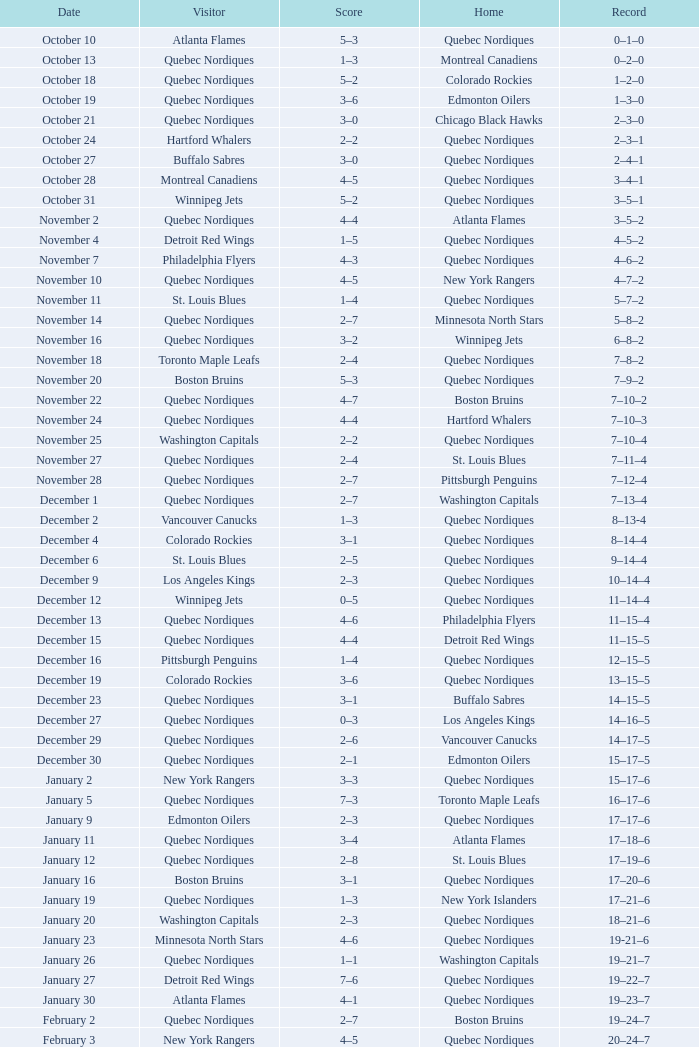Could you parse the entire table? {'header': ['Date', 'Visitor', 'Score', 'Home', 'Record'], 'rows': [['October 10', 'Atlanta Flames', '5–3', 'Quebec Nordiques', '0–1–0'], ['October 13', 'Quebec Nordiques', '1–3', 'Montreal Canadiens', '0–2–0'], ['October 18', 'Quebec Nordiques', '5–2', 'Colorado Rockies', '1–2–0'], ['October 19', 'Quebec Nordiques', '3–6', 'Edmonton Oilers', '1–3–0'], ['October 21', 'Quebec Nordiques', '3–0', 'Chicago Black Hawks', '2–3–0'], ['October 24', 'Hartford Whalers', '2–2', 'Quebec Nordiques', '2–3–1'], ['October 27', 'Buffalo Sabres', '3–0', 'Quebec Nordiques', '2–4–1'], ['October 28', 'Montreal Canadiens', '4–5', 'Quebec Nordiques', '3–4–1'], ['October 31', 'Winnipeg Jets', '5–2', 'Quebec Nordiques', '3–5–1'], ['November 2', 'Quebec Nordiques', '4–4', 'Atlanta Flames', '3–5–2'], ['November 4', 'Detroit Red Wings', '1–5', 'Quebec Nordiques', '4–5–2'], ['November 7', 'Philadelphia Flyers', '4–3', 'Quebec Nordiques', '4–6–2'], ['November 10', 'Quebec Nordiques', '4–5', 'New York Rangers', '4–7–2'], ['November 11', 'St. Louis Blues', '1–4', 'Quebec Nordiques', '5–7–2'], ['November 14', 'Quebec Nordiques', '2–7', 'Minnesota North Stars', '5–8–2'], ['November 16', 'Quebec Nordiques', '3–2', 'Winnipeg Jets', '6–8–2'], ['November 18', 'Toronto Maple Leafs', '2–4', 'Quebec Nordiques', '7–8–2'], ['November 20', 'Boston Bruins', '5–3', 'Quebec Nordiques', '7–9–2'], ['November 22', 'Quebec Nordiques', '4–7', 'Boston Bruins', '7–10–2'], ['November 24', 'Quebec Nordiques', '4–4', 'Hartford Whalers', '7–10–3'], ['November 25', 'Washington Capitals', '2–2', 'Quebec Nordiques', '7–10–4'], ['November 27', 'Quebec Nordiques', '2–4', 'St. Louis Blues', '7–11–4'], ['November 28', 'Quebec Nordiques', '2–7', 'Pittsburgh Penguins', '7–12–4'], ['December 1', 'Quebec Nordiques', '2–7', 'Washington Capitals', '7–13–4'], ['December 2', 'Vancouver Canucks', '1–3', 'Quebec Nordiques', '8–13-4'], ['December 4', 'Colorado Rockies', '3–1', 'Quebec Nordiques', '8–14–4'], ['December 6', 'St. Louis Blues', '2–5', 'Quebec Nordiques', '9–14–4'], ['December 9', 'Los Angeles Kings', '2–3', 'Quebec Nordiques', '10–14–4'], ['December 12', 'Winnipeg Jets', '0–5', 'Quebec Nordiques', '11–14–4'], ['December 13', 'Quebec Nordiques', '4–6', 'Philadelphia Flyers', '11–15–4'], ['December 15', 'Quebec Nordiques', '4–4', 'Detroit Red Wings', '11–15–5'], ['December 16', 'Pittsburgh Penguins', '1–4', 'Quebec Nordiques', '12–15–5'], ['December 19', 'Colorado Rockies', '3–6', 'Quebec Nordiques', '13–15–5'], ['December 23', 'Quebec Nordiques', '3–1', 'Buffalo Sabres', '14–15–5'], ['December 27', 'Quebec Nordiques', '0–3', 'Los Angeles Kings', '14–16–5'], ['December 29', 'Quebec Nordiques', '2–6', 'Vancouver Canucks', '14–17–5'], ['December 30', 'Quebec Nordiques', '2–1', 'Edmonton Oilers', '15–17–5'], ['January 2', 'New York Rangers', '3–3', 'Quebec Nordiques', '15–17–6'], ['January 5', 'Quebec Nordiques', '7–3', 'Toronto Maple Leafs', '16–17–6'], ['January 9', 'Edmonton Oilers', '2–3', 'Quebec Nordiques', '17–17–6'], ['January 11', 'Quebec Nordiques', '3–4', 'Atlanta Flames', '17–18–6'], ['January 12', 'Quebec Nordiques', '2–8', 'St. Louis Blues', '17–19–6'], ['January 16', 'Boston Bruins', '3–1', 'Quebec Nordiques', '17–20–6'], ['January 19', 'Quebec Nordiques', '1–3', 'New York Islanders', '17–21–6'], ['January 20', 'Washington Capitals', '2–3', 'Quebec Nordiques', '18–21–6'], ['January 23', 'Minnesota North Stars', '4–6', 'Quebec Nordiques', '19-21–6'], ['January 26', 'Quebec Nordiques', '1–1', 'Washington Capitals', '19–21–7'], ['January 27', 'Detroit Red Wings', '7–6', 'Quebec Nordiques', '19–22–7'], ['January 30', 'Atlanta Flames', '4–1', 'Quebec Nordiques', '19–23–7'], ['February 2', 'Quebec Nordiques', '2–7', 'Boston Bruins', '19–24–7'], ['February 3', 'New York Rangers', '4–5', 'Quebec Nordiques', '20–24–7'], ['February 6', 'Chicago Black Hawks', '3–3', 'Quebec Nordiques', '20–24–8'], ['February 9', 'Quebec Nordiques', '0–5', 'New York Islanders', '20–25–8'], ['February 10', 'Quebec Nordiques', '1–3', 'New York Rangers', '20–26–8'], ['February 14', 'Quebec Nordiques', '1–5', 'Montreal Canadiens', '20–27–8'], ['February 17', 'Quebec Nordiques', '5–6', 'Winnipeg Jets', '20–28–8'], ['February 18', 'Quebec Nordiques', '2–6', 'Minnesota North Stars', '20–29–8'], ['February 19', 'Buffalo Sabres', '3–1', 'Quebec Nordiques', '20–30–8'], ['February 23', 'Quebec Nordiques', '1–2', 'Pittsburgh Penguins', '20–31–8'], ['February 24', 'Pittsburgh Penguins', '0–2', 'Quebec Nordiques', '21–31–8'], ['February 26', 'Hartford Whalers', '5–9', 'Quebec Nordiques', '22–31–8'], ['February 27', 'New York Islanders', '5–3', 'Quebec Nordiques', '22–32–8'], ['March 2', 'Los Angeles Kings', '4–3', 'Quebec Nordiques', '22–33–8'], ['March 5', 'Minnesota North Stars', '3-3', 'Quebec Nordiques', '22–33–9'], ['March 8', 'Quebec Nordiques', '2–3', 'Toronto Maple Leafs', '22–34–9'], ['March 9', 'Toronto Maple Leafs', '4–5', 'Quebec Nordiques', '23–34-9'], ['March 12', 'Edmonton Oilers', '6–3', 'Quebec Nordiques', '23–35–9'], ['March 16', 'Vancouver Canucks', '3–2', 'Quebec Nordiques', '23–36–9'], ['March 19', 'Quebec Nordiques', '2–5', 'Chicago Black Hawks', '23–37–9'], ['March 20', 'Quebec Nordiques', '6–2', 'Colorado Rockies', '24–37–9'], ['March 22', 'Quebec Nordiques', '1-4', 'Los Angeles Kings', '24–38-9'], ['March 23', 'Quebec Nordiques', '6–2', 'Vancouver Canucks', '25–38–9'], ['March 26', 'Chicago Black Hawks', '7–2', 'Quebec Nordiques', '25–39–9'], ['March 27', 'Quebec Nordiques', '2–5', 'Philadelphia Flyers', '25–40–9'], ['March 29', 'Quebec Nordiques', '7–9', 'Detroit Red Wings', '25–41–9'], ['March 30', 'New York Islanders', '9–6', 'Quebec Nordiques', '25–42–9'], ['April 1', 'Philadelphia Flyers', '3–3', 'Quebec Nordiques', '25–42–10'], ['April 3', 'Quebec Nordiques', '3–8', 'Buffalo Sabres', '25–43–10'], ['April 4', 'Quebec Nordiques', '2–9', 'Hartford Whalers', '25–44–10'], ['April 6', 'Montreal Canadiens', '4–4', 'Quebec Nordiques', '25–44–11']]} In which home can a 16-17-6 track record be found? Toronto Maple Leafs. 